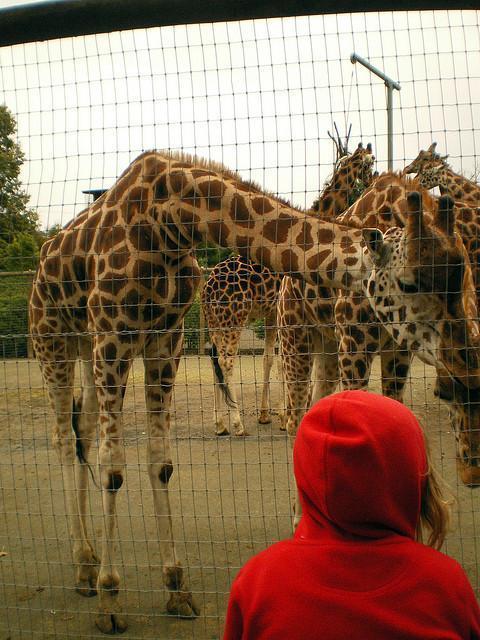How many giraffes are there?
Give a very brief answer. 6. How many toilet rolls are reflected in the mirror?
Give a very brief answer. 0. 